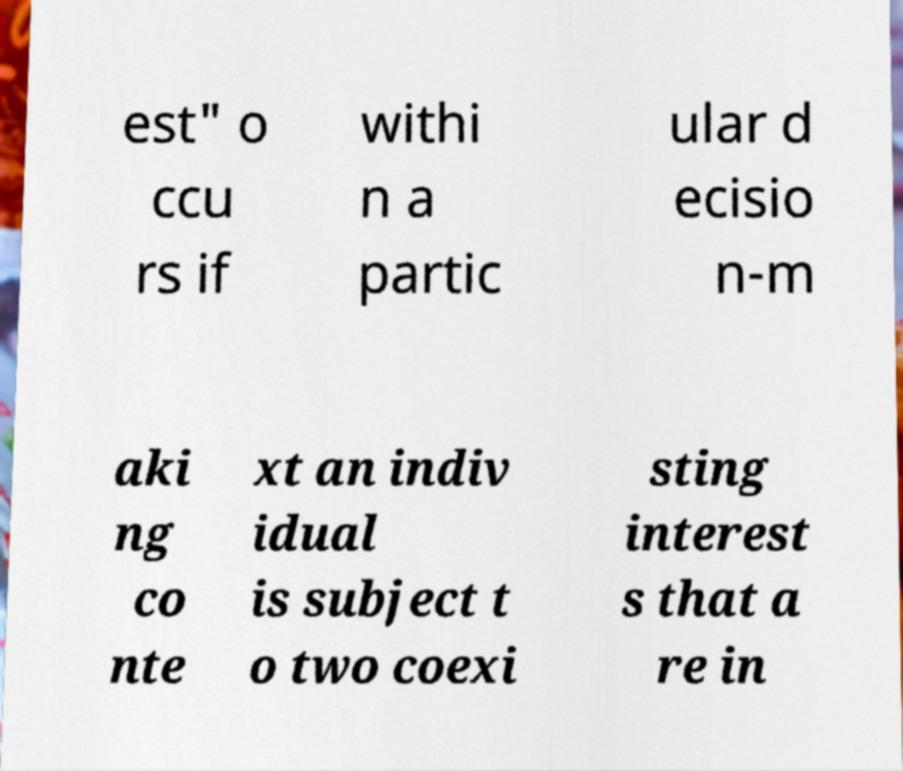I need the written content from this picture converted into text. Can you do that? est" o ccu rs if withi n a partic ular d ecisio n-m aki ng co nte xt an indiv idual is subject t o two coexi sting interest s that a re in 